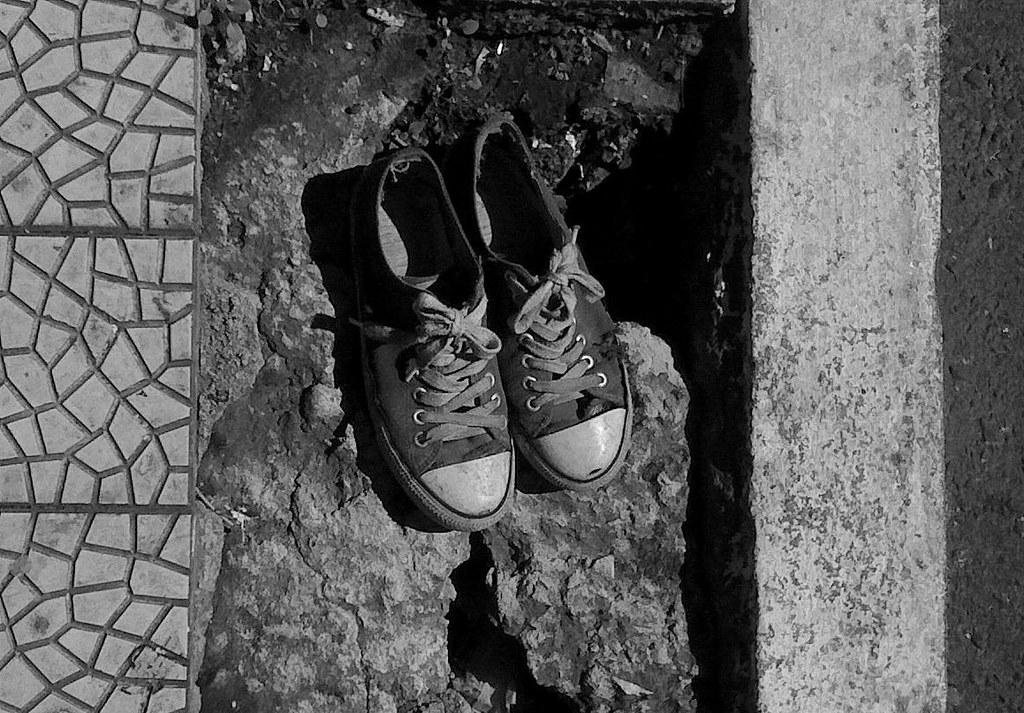What is the color scheme of the image? The image is black and white. What is the main subject of the image? There is a pair of shoes in the middle of the image. What type of surface is visible on the left side of the image? There is a tile surface on the left side of the image. What type of drum can be seen in the image? There is no drum present in the image; it features a pair of shoes and a tile surface. What type of trousers are the people wearing in the image? There are no people visible in the image, only a pair of shoes and a tile surface. 